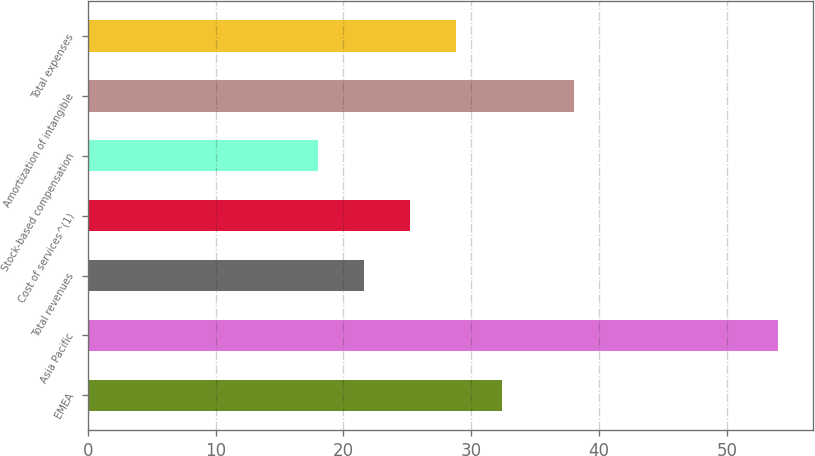Convert chart. <chart><loc_0><loc_0><loc_500><loc_500><bar_chart><fcel>EMEA<fcel>Asia Pacific<fcel>Total revenues<fcel>Cost of services^(1)<fcel>Stock-based compensation<fcel>Amortization of intangible<fcel>Total expenses<nl><fcel>32.4<fcel>54<fcel>21.6<fcel>25.2<fcel>18<fcel>38<fcel>28.8<nl></chart> 